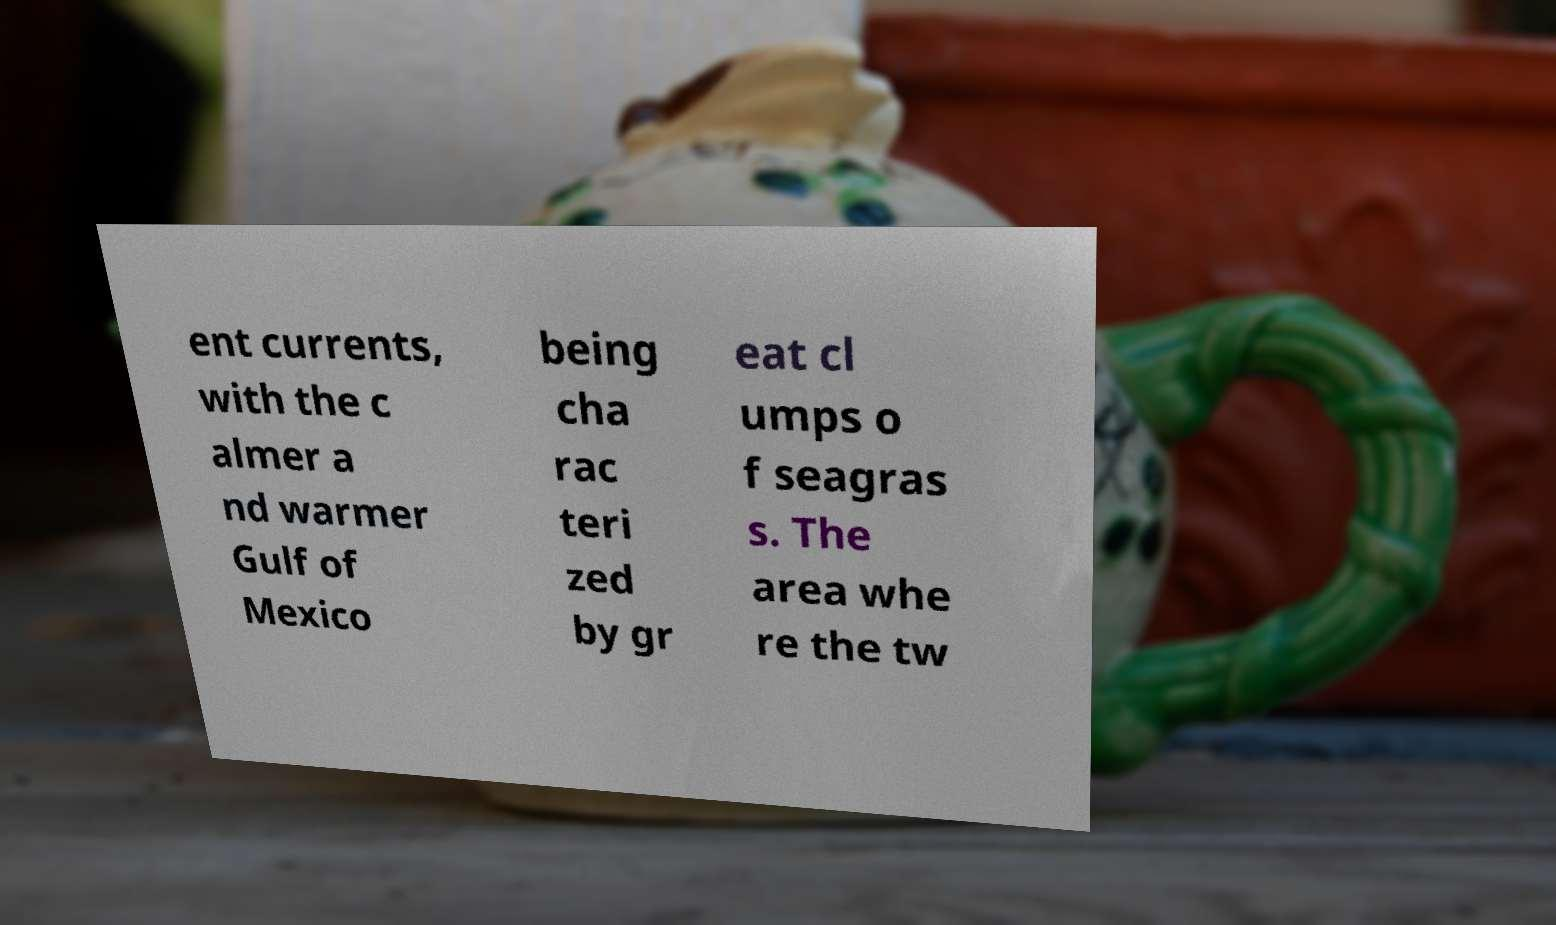Please identify and transcribe the text found in this image. ent currents, with the c almer a nd warmer Gulf of Mexico being cha rac teri zed by gr eat cl umps o f seagras s. The area whe re the tw 